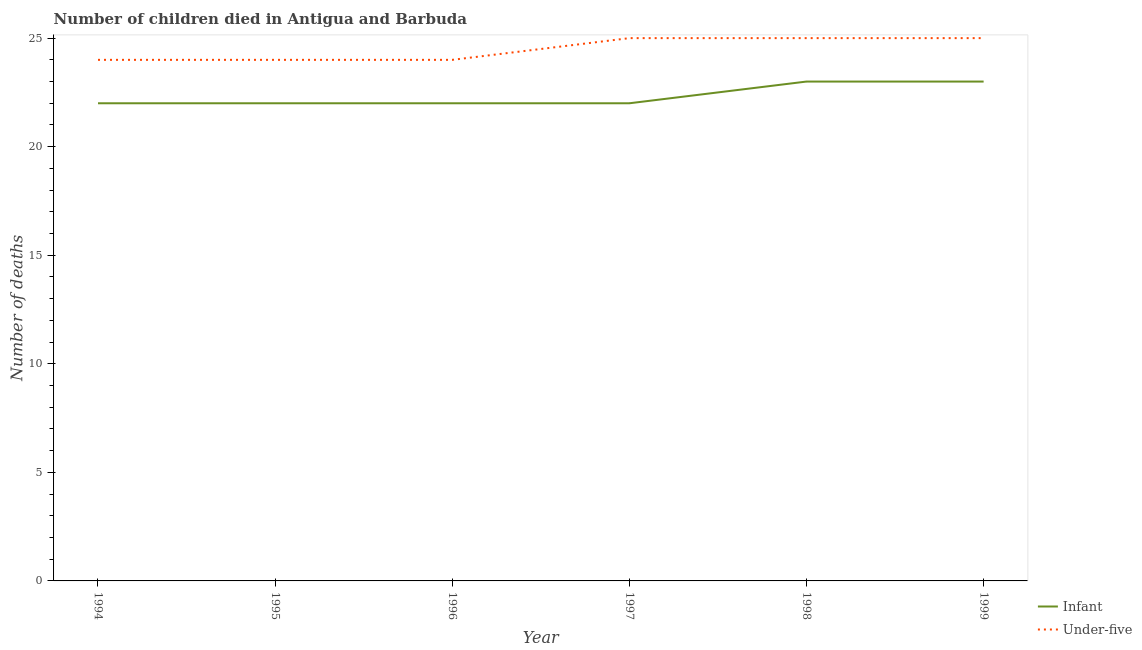How many different coloured lines are there?
Ensure brevity in your answer.  2. Is the number of lines equal to the number of legend labels?
Give a very brief answer. Yes. What is the number of under-five deaths in 1996?
Offer a very short reply. 24. Across all years, what is the maximum number of under-five deaths?
Offer a very short reply. 25. Across all years, what is the minimum number of infant deaths?
Give a very brief answer. 22. In which year was the number of infant deaths maximum?
Make the answer very short. 1998. What is the total number of under-five deaths in the graph?
Provide a short and direct response. 147. What is the difference between the number of under-five deaths in 1994 and that in 1997?
Make the answer very short. -1. What is the difference between the number of under-five deaths in 1997 and the number of infant deaths in 1995?
Ensure brevity in your answer.  3. What is the average number of infant deaths per year?
Your response must be concise. 22.33. In the year 1997, what is the difference between the number of infant deaths and number of under-five deaths?
Your response must be concise. -3. What is the ratio of the number of infant deaths in 1995 to that in 1996?
Offer a terse response. 1. Is the difference between the number of infant deaths in 1998 and 1999 greater than the difference between the number of under-five deaths in 1998 and 1999?
Your answer should be compact. No. What is the difference between the highest and the second highest number of under-five deaths?
Your answer should be compact. 0. What is the difference between the highest and the lowest number of infant deaths?
Give a very brief answer. 1. In how many years, is the number of infant deaths greater than the average number of infant deaths taken over all years?
Provide a short and direct response. 2. Is the number of under-five deaths strictly greater than the number of infant deaths over the years?
Provide a succinct answer. Yes. Is the number of under-five deaths strictly less than the number of infant deaths over the years?
Offer a very short reply. No. How many years are there in the graph?
Make the answer very short. 6. Does the graph contain grids?
Provide a succinct answer. No. What is the title of the graph?
Give a very brief answer. Number of children died in Antigua and Barbuda. What is the label or title of the Y-axis?
Provide a short and direct response. Number of deaths. What is the Number of deaths of Infant in 1994?
Give a very brief answer. 22. What is the Number of deaths in Under-five in 1994?
Give a very brief answer. 24. What is the Number of deaths in Under-five in 1995?
Your answer should be very brief. 24. What is the Number of deaths in Under-five in 1997?
Ensure brevity in your answer.  25. What is the Number of deaths in Infant in 1999?
Your response must be concise. 23. Across all years, what is the maximum Number of deaths of Under-five?
Your answer should be very brief. 25. Across all years, what is the minimum Number of deaths of Infant?
Ensure brevity in your answer.  22. What is the total Number of deaths in Infant in the graph?
Your answer should be very brief. 134. What is the total Number of deaths in Under-five in the graph?
Your answer should be very brief. 147. What is the difference between the Number of deaths in Under-five in 1994 and that in 1995?
Your answer should be compact. 0. What is the difference between the Number of deaths of Under-five in 1994 and that in 1996?
Your response must be concise. 0. What is the difference between the Number of deaths of Infant in 1994 and that in 1997?
Give a very brief answer. 0. What is the difference between the Number of deaths of Infant in 1994 and that in 1998?
Make the answer very short. -1. What is the difference between the Number of deaths of Under-five in 1994 and that in 1999?
Make the answer very short. -1. What is the difference between the Number of deaths of Under-five in 1995 and that in 1996?
Provide a succinct answer. 0. What is the difference between the Number of deaths of Infant in 1995 and that in 1997?
Make the answer very short. 0. What is the difference between the Number of deaths in Infant in 1995 and that in 1998?
Provide a short and direct response. -1. What is the difference between the Number of deaths of Under-five in 1995 and that in 1998?
Provide a short and direct response. -1. What is the difference between the Number of deaths of Infant in 1995 and that in 1999?
Ensure brevity in your answer.  -1. What is the difference between the Number of deaths in Under-five in 1995 and that in 1999?
Make the answer very short. -1. What is the difference between the Number of deaths of Infant in 1996 and that in 1997?
Make the answer very short. 0. What is the difference between the Number of deaths of Under-five in 1996 and that in 1997?
Ensure brevity in your answer.  -1. What is the difference between the Number of deaths of Infant in 1996 and that in 1998?
Give a very brief answer. -1. What is the difference between the Number of deaths of Under-five in 1996 and that in 1999?
Offer a terse response. -1. What is the difference between the Number of deaths of Infant in 1997 and that in 1999?
Offer a terse response. -1. What is the difference between the Number of deaths of Under-five in 1997 and that in 1999?
Your response must be concise. 0. What is the difference between the Number of deaths of Under-five in 1998 and that in 1999?
Offer a terse response. 0. What is the difference between the Number of deaths in Infant in 1994 and the Number of deaths in Under-five in 1996?
Your answer should be compact. -2. What is the difference between the Number of deaths of Infant in 1994 and the Number of deaths of Under-five in 1997?
Offer a terse response. -3. What is the difference between the Number of deaths of Infant in 1994 and the Number of deaths of Under-five in 1998?
Provide a succinct answer. -3. What is the difference between the Number of deaths in Infant in 1995 and the Number of deaths in Under-five in 1997?
Ensure brevity in your answer.  -3. What is the difference between the Number of deaths of Infant in 1995 and the Number of deaths of Under-five in 1998?
Your answer should be compact. -3. What is the difference between the Number of deaths in Infant in 1996 and the Number of deaths in Under-five in 1998?
Make the answer very short. -3. What is the difference between the Number of deaths of Infant in 1997 and the Number of deaths of Under-five in 1999?
Your answer should be very brief. -3. What is the average Number of deaths of Infant per year?
Give a very brief answer. 22.33. In the year 1995, what is the difference between the Number of deaths in Infant and Number of deaths in Under-five?
Offer a very short reply. -2. In the year 1997, what is the difference between the Number of deaths in Infant and Number of deaths in Under-five?
Offer a terse response. -3. In the year 1999, what is the difference between the Number of deaths in Infant and Number of deaths in Under-five?
Keep it short and to the point. -2. What is the ratio of the Number of deaths of Infant in 1994 to that in 1995?
Make the answer very short. 1. What is the ratio of the Number of deaths of Under-five in 1994 to that in 1997?
Your response must be concise. 0.96. What is the ratio of the Number of deaths of Infant in 1994 to that in 1998?
Offer a terse response. 0.96. What is the ratio of the Number of deaths in Under-five in 1994 to that in 1998?
Make the answer very short. 0.96. What is the ratio of the Number of deaths of Infant in 1994 to that in 1999?
Keep it short and to the point. 0.96. What is the ratio of the Number of deaths in Under-five in 1994 to that in 1999?
Provide a succinct answer. 0.96. What is the ratio of the Number of deaths of Infant in 1995 to that in 1998?
Offer a very short reply. 0.96. What is the ratio of the Number of deaths in Under-five in 1995 to that in 1998?
Offer a terse response. 0.96. What is the ratio of the Number of deaths of Infant in 1995 to that in 1999?
Ensure brevity in your answer.  0.96. What is the ratio of the Number of deaths of Under-five in 1996 to that in 1997?
Make the answer very short. 0.96. What is the ratio of the Number of deaths in Infant in 1996 to that in 1998?
Provide a succinct answer. 0.96. What is the ratio of the Number of deaths of Under-five in 1996 to that in 1998?
Make the answer very short. 0.96. What is the ratio of the Number of deaths in Infant in 1996 to that in 1999?
Provide a short and direct response. 0.96. What is the ratio of the Number of deaths of Infant in 1997 to that in 1998?
Provide a short and direct response. 0.96. What is the ratio of the Number of deaths of Infant in 1997 to that in 1999?
Your response must be concise. 0.96. What is the ratio of the Number of deaths of Infant in 1998 to that in 1999?
Give a very brief answer. 1. What is the ratio of the Number of deaths in Under-five in 1998 to that in 1999?
Provide a short and direct response. 1. What is the difference between the highest and the second highest Number of deaths of Under-five?
Your answer should be very brief. 0. 